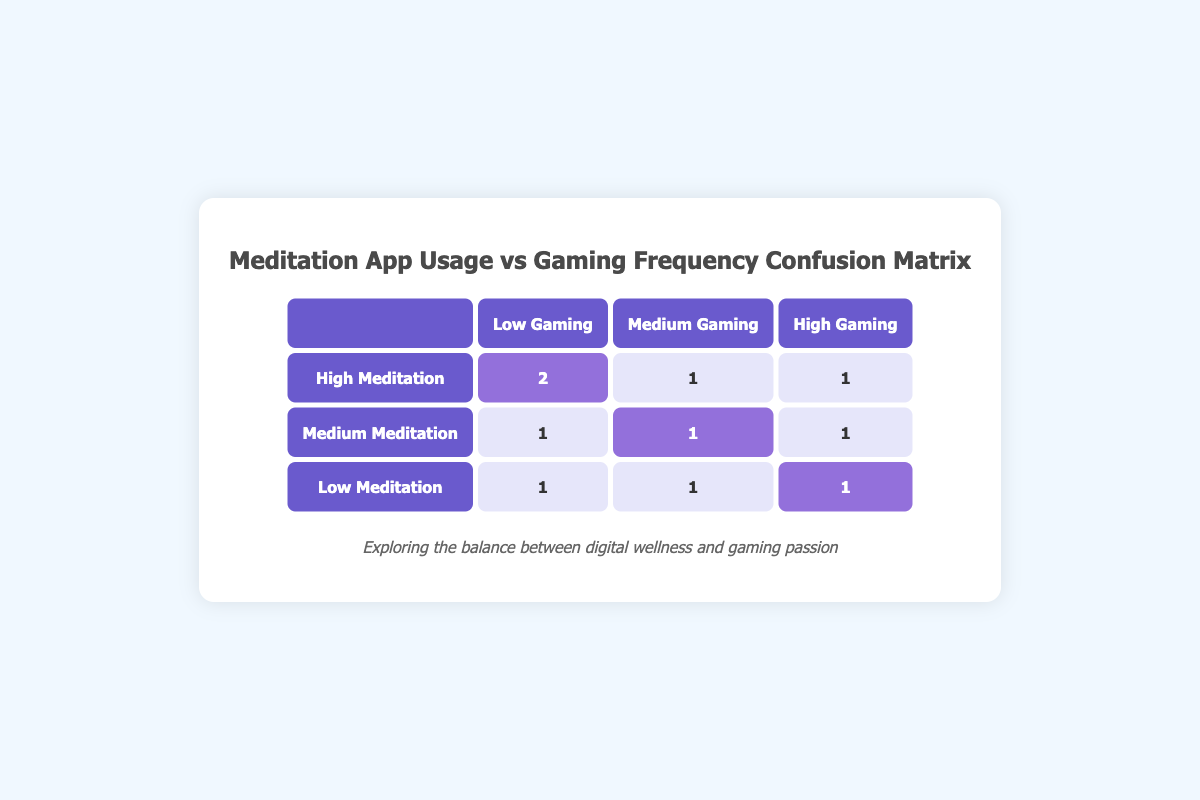What is the count of users with High Meditation and Low Gaming? Referring to the table, the cell where High Meditation and Low Gaming intersect shows a value of 2. This indicates that 2 users fall under this category.
Answer: 2 How many users use Medium Meditation and engage in High Gaming? In the table, the intersection of Medium Meditation and High Gaming shows a value of 1. Therefore, there is 1 user in this group.
Answer: 1 Is there any user who meditates Low and also games Low? Looking at the table, the intersection of Low Meditation and Low Gaming has a value of 1, meaning there is at least one user who fits this profile.
Answer: Yes What is the total number of users who meditate at a Medium level? To find the total for Medium Meditation, we add the values across gaming frequencies: 1 (Low) + 1 (Medium) + 1 (High) = 3. Thus, there are 3 users using Medium Meditation.
Answer: 3 Which combination of Meditation and Gaming has the highest frequency? By reviewing the highest values in the table, the combination of High Meditation with Low Gaming shows the highest number, which is 2. Therefore, this combination has the highest frequency.
Answer: High Meditation and Low Gaming What is the average number of users for each meditation category? To calculate this, we sum the values in each row: High (4) + Medium (3) + Low (3) = 10 total users. Dividing by the number of meditation categories (3) gives us an average of 10/3 = approximately 3.33.
Answer: Approximately 3.33 How many users engage in High Gaming while also having High Meditation? From the table, the cell marked for High Meditation and High Gaming shows a value of 1. Therefore, there is 1 user who participates in both activities at a high level.
Answer: 1 What is the difference in user count between Low Meditation and Medium Meditation across all gaming frequencies? The total for Low Meditation is 3 (1+1+1) and for Medium Meditation is 3 (1+1+1) as well. Thus, the difference is 3 - 3 = 0. Therefore, there is no difference in user count between the two mediation levels.
Answer: 0 Which gaming frequency has the least number of users in the Low Meditation category? For the Low Meditation row, the counts for different gaming frequencies are all equal, with a value of 1 for each range (Low, Medium, High). Therefore, there is no unique lowest; each has the same count.
Answer: None (all equal) 